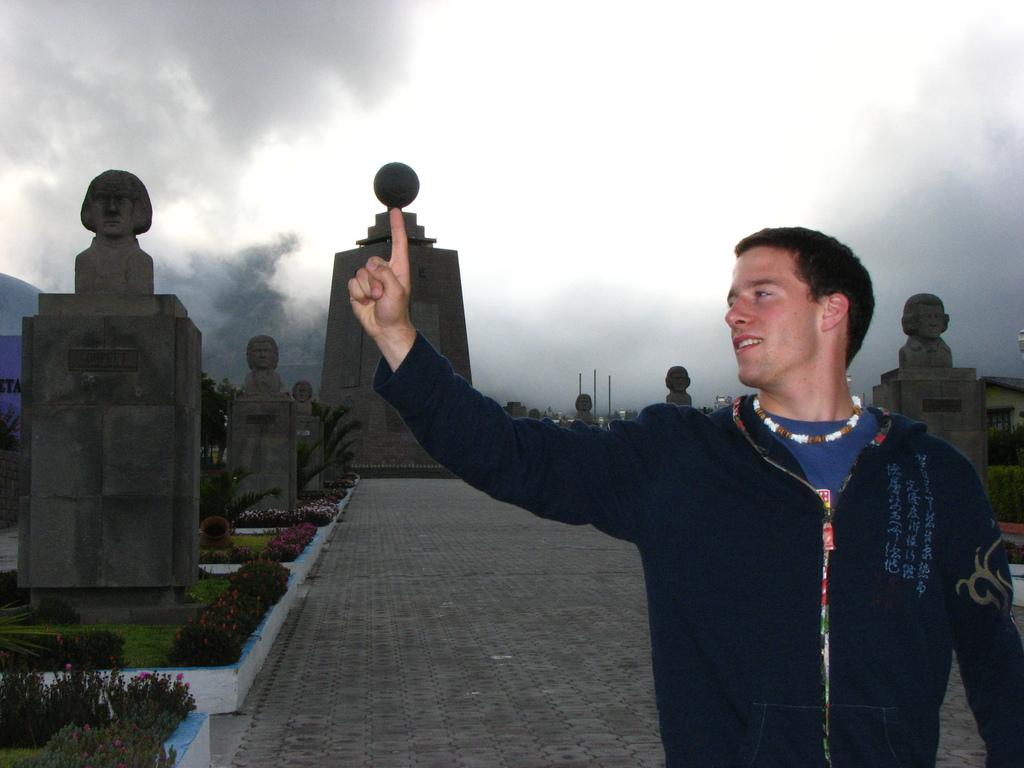What is the person on the right side of the image wearing? The person is wearing a jacket. What can be seen on the left side of the image? There are statues on stands on the left side of the image. What type of vegetation is present in the image? There are plants and grass in the image. What is the weather condition in the background of the image? There is fog in the background of the image. What shape is the popcorn in the image? There is no popcorn present in the image. What does the person's mom say about the statues on stands? There is no reference to the person's mom or any dialogue in the image. 